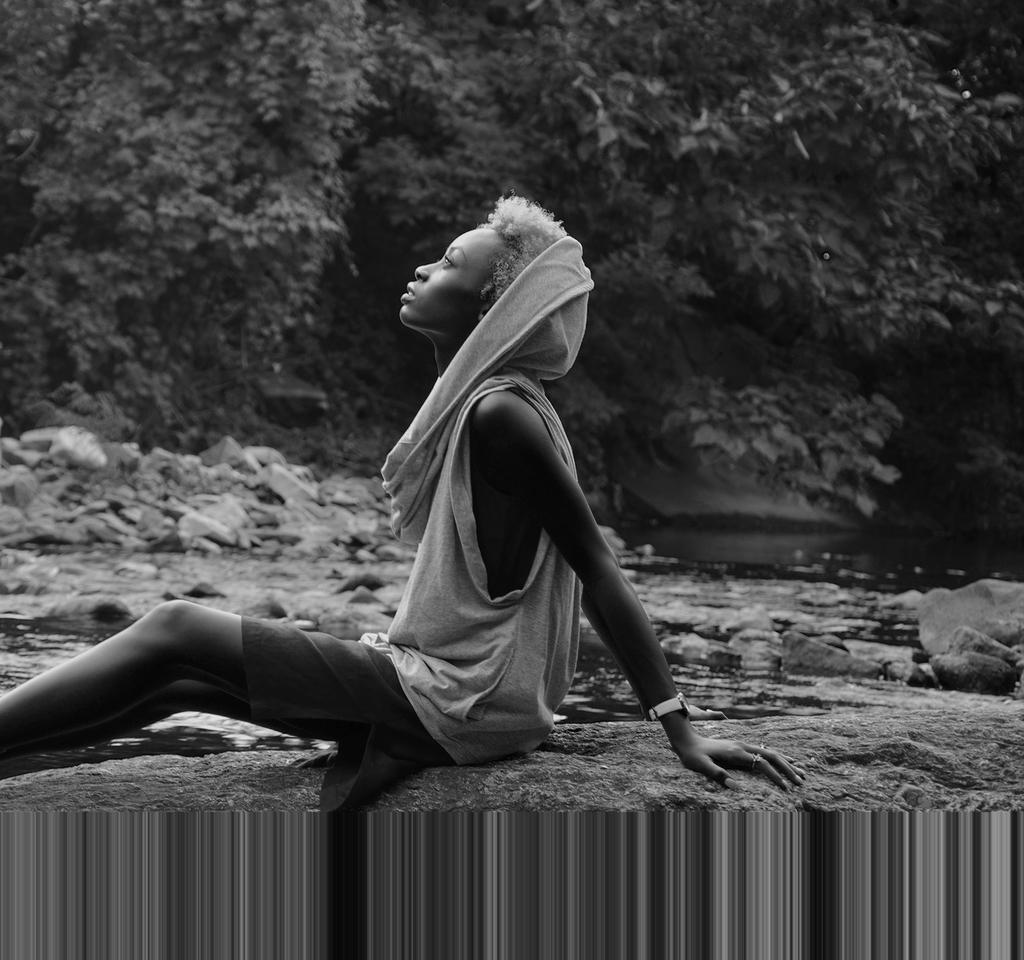What type of image is present in the picture? There is a black and white photograph in the image. Who is the subject of the photograph? The photograph is of a girl. What is the girl doing in the photograph? The girl is sitting on the ground and looking up. What can be seen in the foreground of the image? There are stones visible in the image. What is visible in the background of the image? There are trees in the background of the image. What type of corn can be seen growing in the patch in the image? There is no corn or patch present in the image; it features a photograph of a girl sitting on the ground and looking up. 